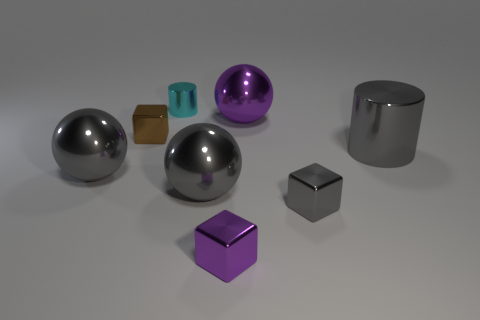Is the number of large things that are in front of the large gray cylinder greater than the number of cyan metal cylinders behind the small brown thing?
Provide a succinct answer. Yes. Is there anything else that has the same color as the tiny cylinder?
Make the answer very short. No. There is a metal block right of the purple metallic sphere to the right of the tiny cyan metallic cylinder; are there any big things that are to the left of it?
Provide a short and direct response. Yes. There is a big gray shiny object on the left side of the small brown thing; is it the same shape as the big purple shiny object?
Make the answer very short. Yes. Is the number of big purple metallic objects on the right side of the tiny cyan object less than the number of gray metallic objects that are on the left side of the small purple object?
Keep it short and to the point. Yes. What is the material of the cyan cylinder?
Keep it short and to the point. Metal. Is the color of the large cylinder the same as the tiny shiny thing on the right side of the large purple object?
Ensure brevity in your answer.  Yes. How many brown shiny objects are on the left side of the small purple metal thing?
Ensure brevity in your answer.  1. Are there fewer large things that are behind the tiny cyan metal object than large metallic objects?
Your answer should be very brief. Yes. What is the color of the tiny cylinder?
Your response must be concise. Cyan. 